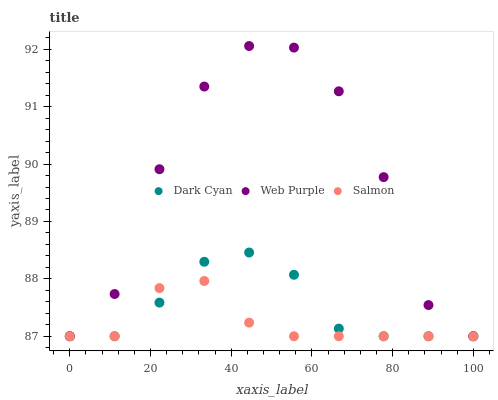Does Salmon have the minimum area under the curve?
Answer yes or no. Yes. Does Web Purple have the maximum area under the curve?
Answer yes or no. Yes. Does Web Purple have the minimum area under the curve?
Answer yes or no. No. Does Salmon have the maximum area under the curve?
Answer yes or no. No. Is Salmon the smoothest?
Answer yes or no. Yes. Is Web Purple the roughest?
Answer yes or no. Yes. Is Web Purple the smoothest?
Answer yes or no. No. Is Salmon the roughest?
Answer yes or no. No. Does Dark Cyan have the lowest value?
Answer yes or no. Yes. Does Web Purple have the highest value?
Answer yes or no. Yes. Does Salmon have the highest value?
Answer yes or no. No. Does Web Purple intersect Salmon?
Answer yes or no. Yes. Is Web Purple less than Salmon?
Answer yes or no. No. Is Web Purple greater than Salmon?
Answer yes or no. No. 